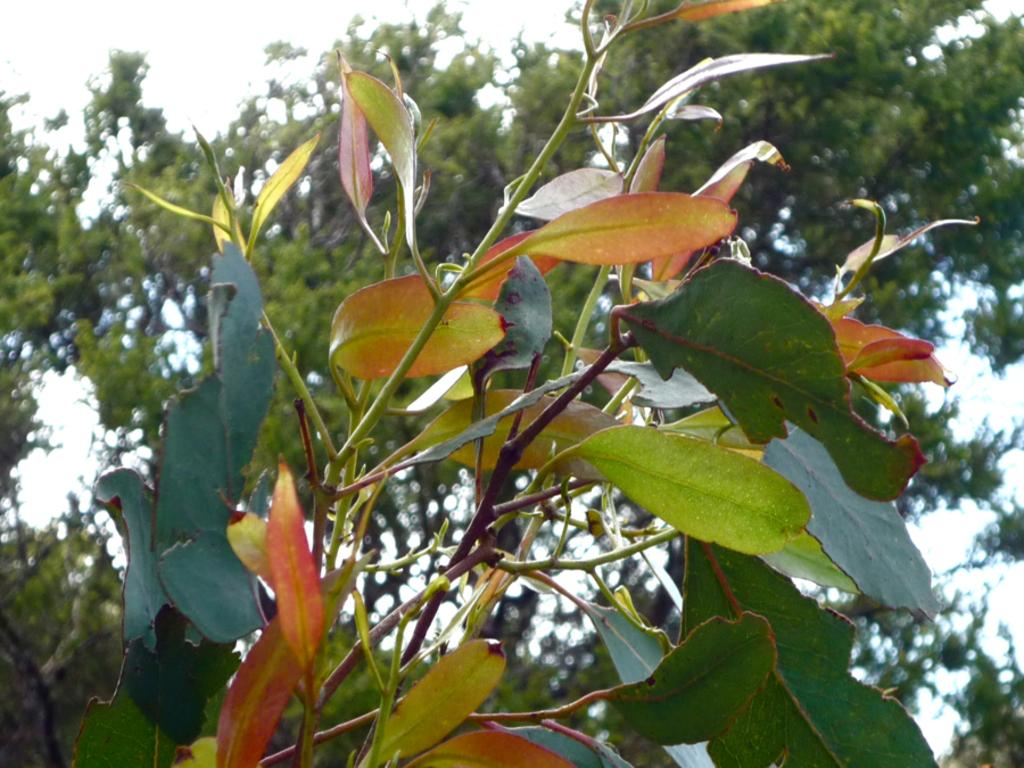What type of vegetation is visible in the front of the image? There are plants in the front of the image. What type of vegetation is visible in the background of the image? There are trees in the background of the image. What is the condition of the sky in the image? The sky is cloudy in the image. How many rings can be seen on the goose in the image? There is no goose or rings present in the image. What type of seashore can be seen in the image? There is no seashore visible in the image; it features plants, trees, and a cloudy sky. 